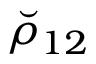Convert formula to latex. <formula><loc_0><loc_0><loc_500><loc_500>\breve { \rho } _ { 1 2 }</formula> 